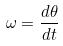Convert formula to latex. <formula><loc_0><loc_0><loc_500><loc_500>\omega = \frac { d \theta } { d t }</formula> 